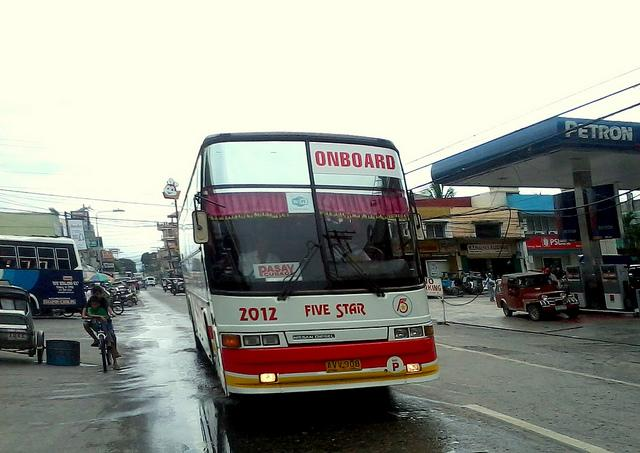Why is the red vehicle on the right stopped at the building?

Choices:
A) to race
B) refueling
C) broke down
D) changing tires refueling 